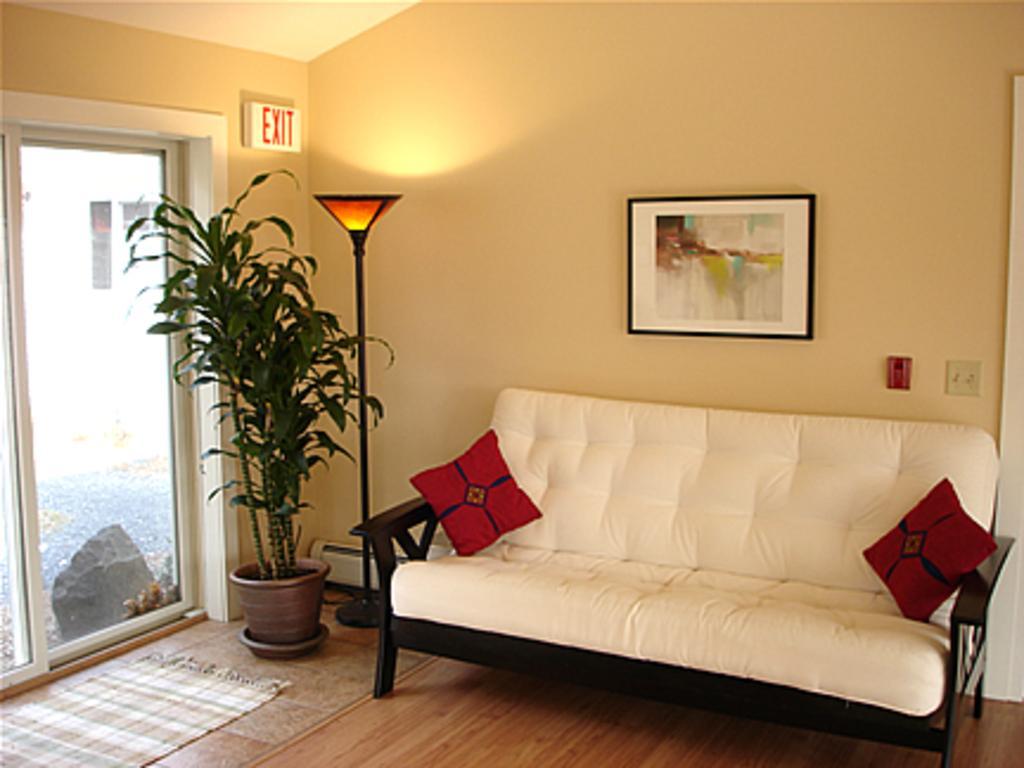How would you summarize this image in a sentence or two? This is inside of the room we can see sofa,light with stand,houseplant,mat on the floor. Behind this sofa we can see wall,frame,on the sofa we can see pillows. This is glass door,from this glass door we can see road,stone. 